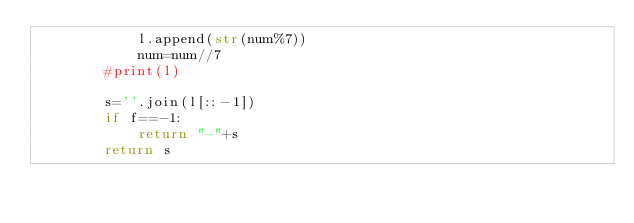<code> <loc_0><loc_0><loc_500><loc_500><_Python_>            l.append(str(num%7))
            num=num//7
        #print(l)    
        
        s=''.join(l[::-1])
        if f==-1:
            return "-"+s
        return s
</code> 